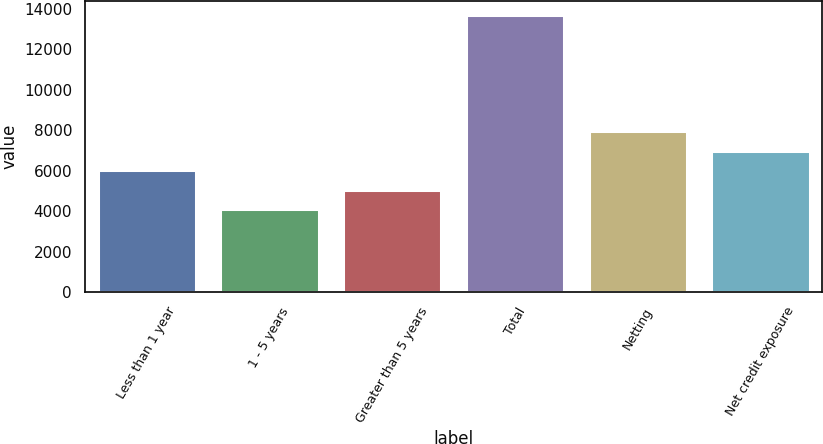<chart> <loc_0><loc_0><loc_500><loc_500><bar_chart><fcel>Less than 1 year<fcel>1 - 5 years<fcel>Greater than 5 years<fcel>Total<fcel>Netting<fcel>Net credit exposure<nl><fcel>6014.6<fcel>4091<fcel>5052.8<fcel>13709<fcel>7938.2<fcel>6976.4<nl></chart> 